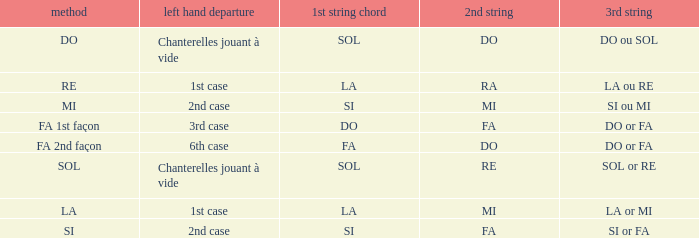For the 2nd string of Ra what is the Depart de la main gauche? 1st case. 